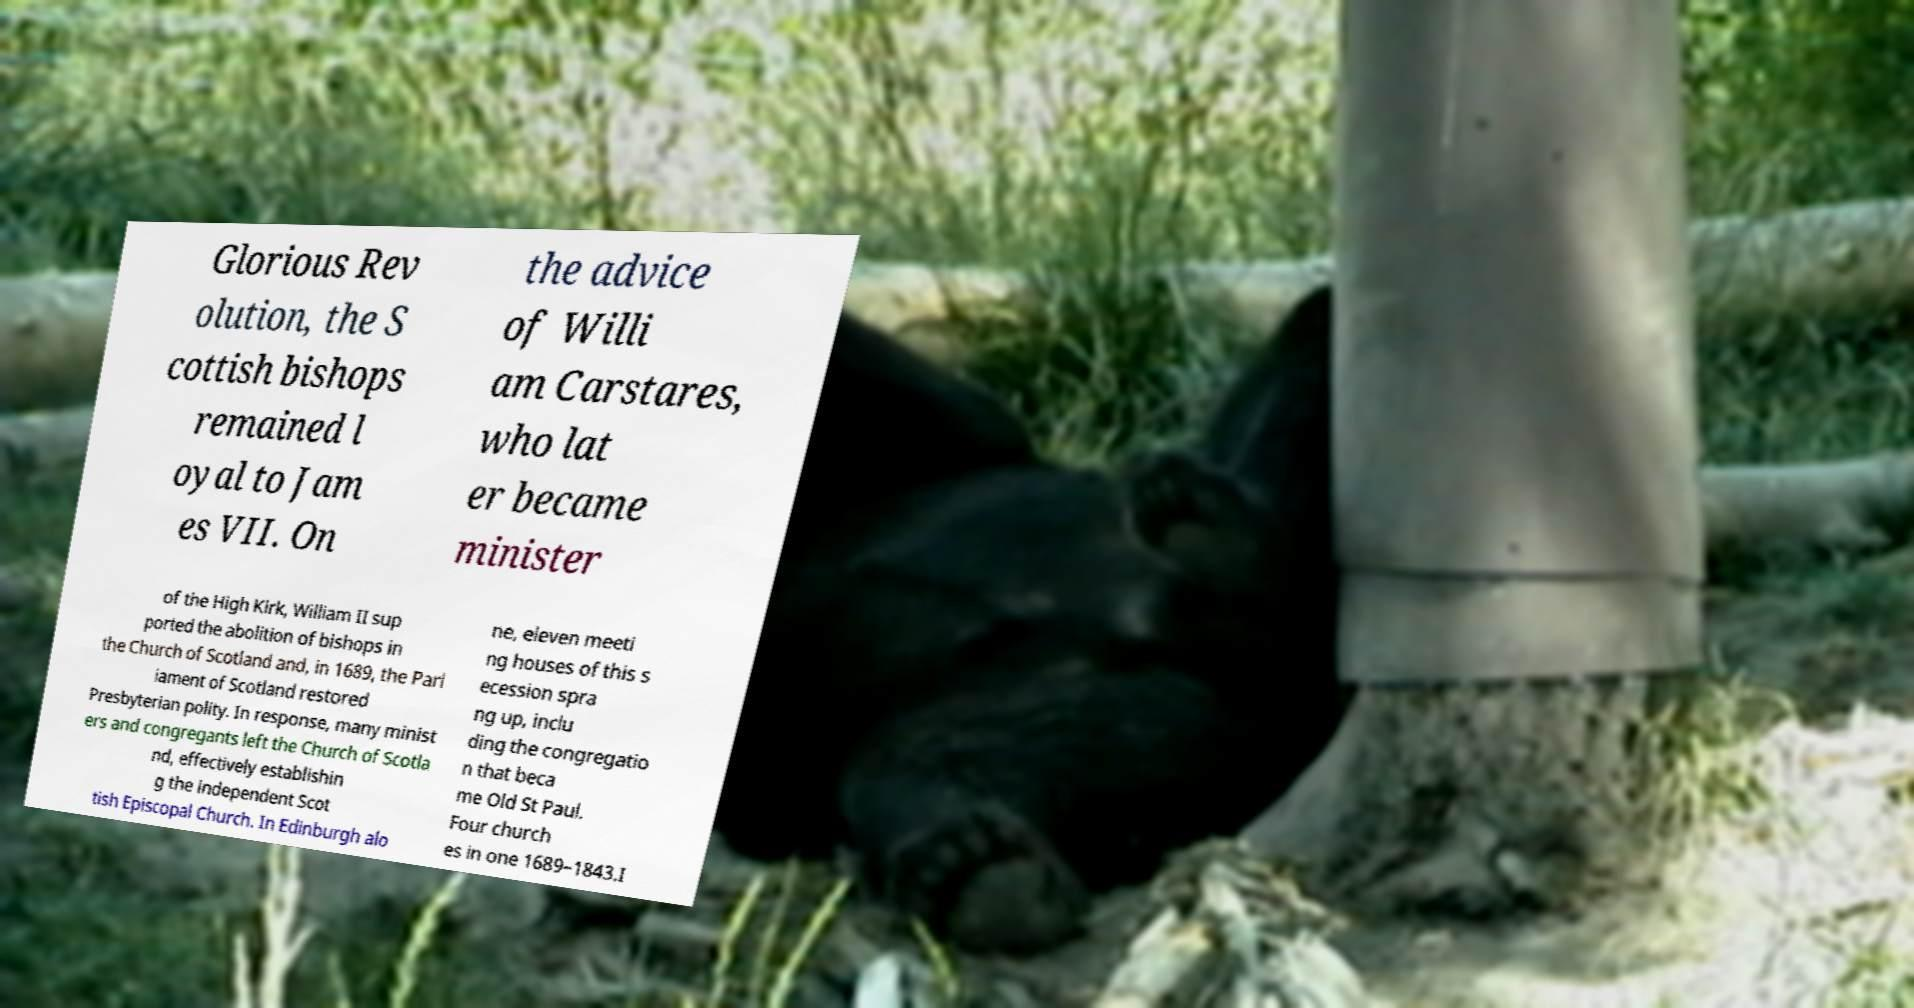Please read and relay the text visible in this image. What does it say? Glorious Rev olution, the S cottish bishops remained l oyal to Jam es VII. On the advice of Willi am Carstares, who lat er became minister of the High Kirk, William II sup ported the abolition of bishops in the Church of Scotland and, in 1689, the Parl iament of Scotland restored Presbyterian polity. In response, many minist ers and congregants left the Church of Scotla nd, effectively establishin g the independent Scot tish Episcopal Church. In Edinburgh alo ne, eleven meeti ng houses of this s ecession spra ng up, inclu ding the congregatio n that beca me Old St Paul. Four church es in one 1689–1843.I 